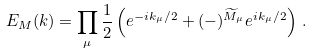<formula> <loc_0><loc_0><loc_500><loc_500>E _ { M } ( k ) = \prod _ { \mu } \frac { 1 } { 2 } \left ( e ^ { - i k _ { \mu } / 2 } + ( - ) ^ { \widetilde { M } _ { \mu } } e ^ { i k _ { \mu } / 2 } \right ) \, .</formula> 